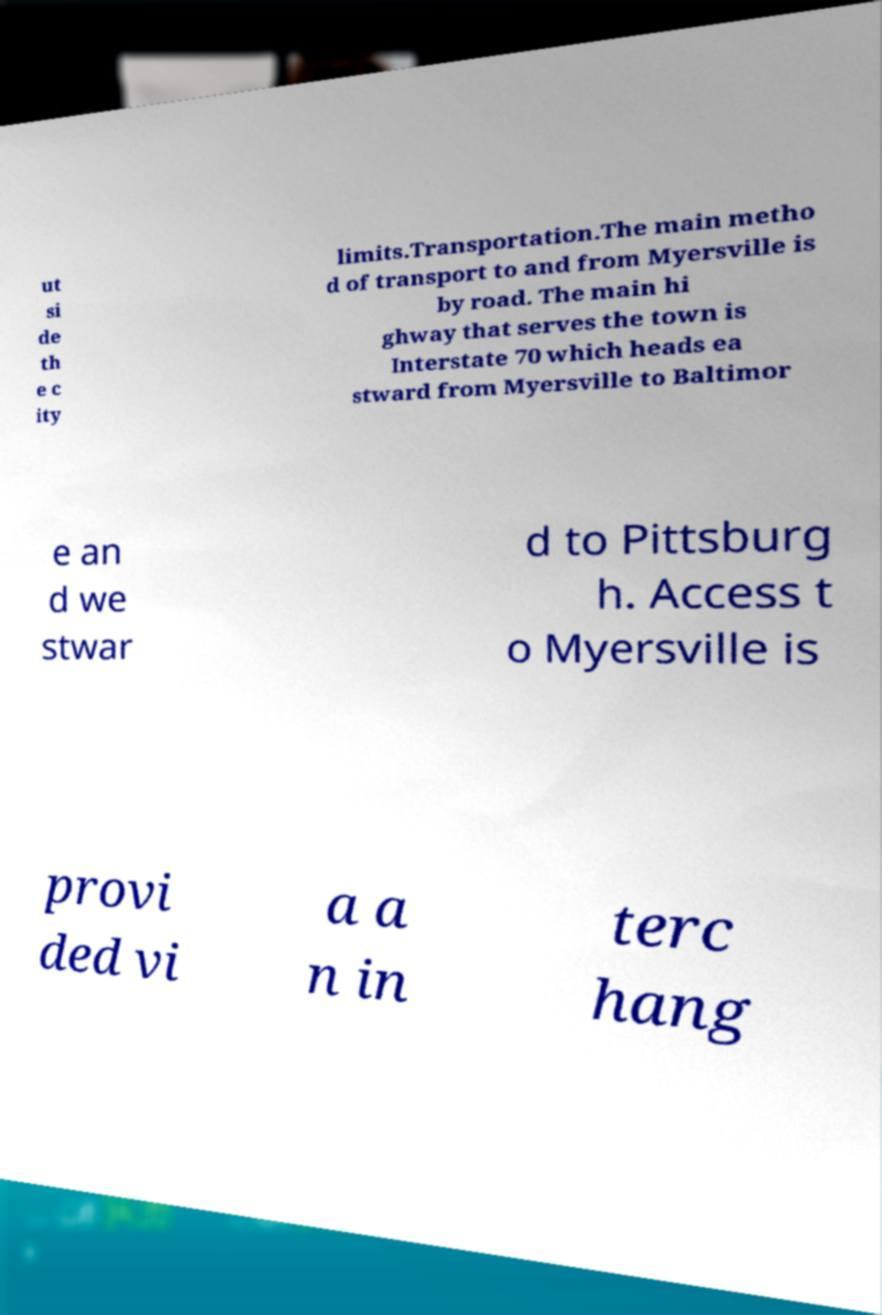For documentation purposes, I need the text within this image transcribed. Could you provide that? ut si de th e c ity limits.Transportation.The main metho d of transport to and from Myersville is by road. The main hi ghway that serves the town is Interstate 70 which heads ea stward from Myersville to Baltimor e an d we stwar d to Pittsburg h. Access t o Myersville is provi ded vi a a n in terc hang 